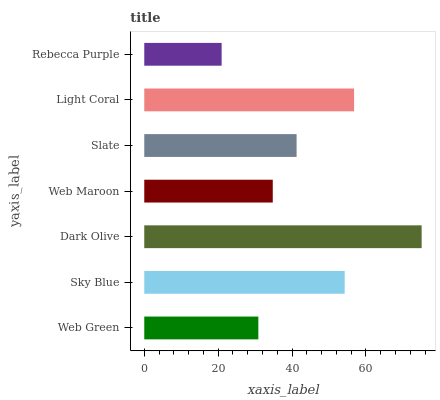Is Rebecca Purple the minimum?
Answer yes or no. Yes. Is Dark Olive the maximum?
Answer yes or no. Yes. Is Sky Blue the minimum?
Answer yes or no. No. Is Sky Blue the maximum?
Answer yes or no. No. Is Sky Blue greater than Web Green?
Answer yes or no. Yes. Is Web Green less than Sky Blue?
Answer yes or no. Yes. Is Web Green greater than Sky Blue?
Answer yes or no. No. Is Sky Blue less than Web Green?
Answer yes or no. No. Is Slate the high median?
Answer yes or no. Yes. Is Slate the low median?
Answer yes or no. Yes. Is Web Maroon the high median?
Answer yes or no. No. Is Dark Olive the low median?
Answer yes or no. No. 